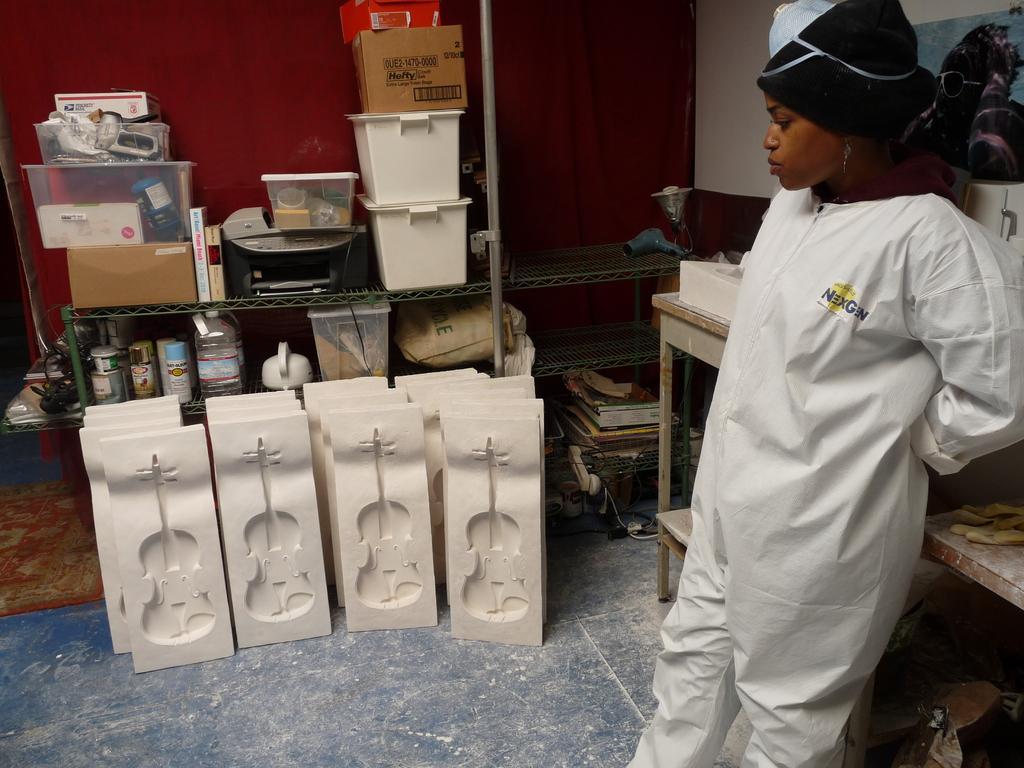How would you summarize this image in a sentence or two? This is the picture of a room. On the right side of the image there is a woman standing at the table and there are objects on the table. On the left side of the image there are boxes, cardboard boxes, bottles, objects and table. There are guitar sculptures. At the back there is a wall. At the bottom there is a floor. 